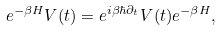<formula> <loc_0><loc_0><loc_500><loc_500>e ^ { - \beta H } V ( t ) = e ^ { i \beta \hbar { \partial } _ { t } } V ( t ) e ^ { - \beta H } ,</formula> 